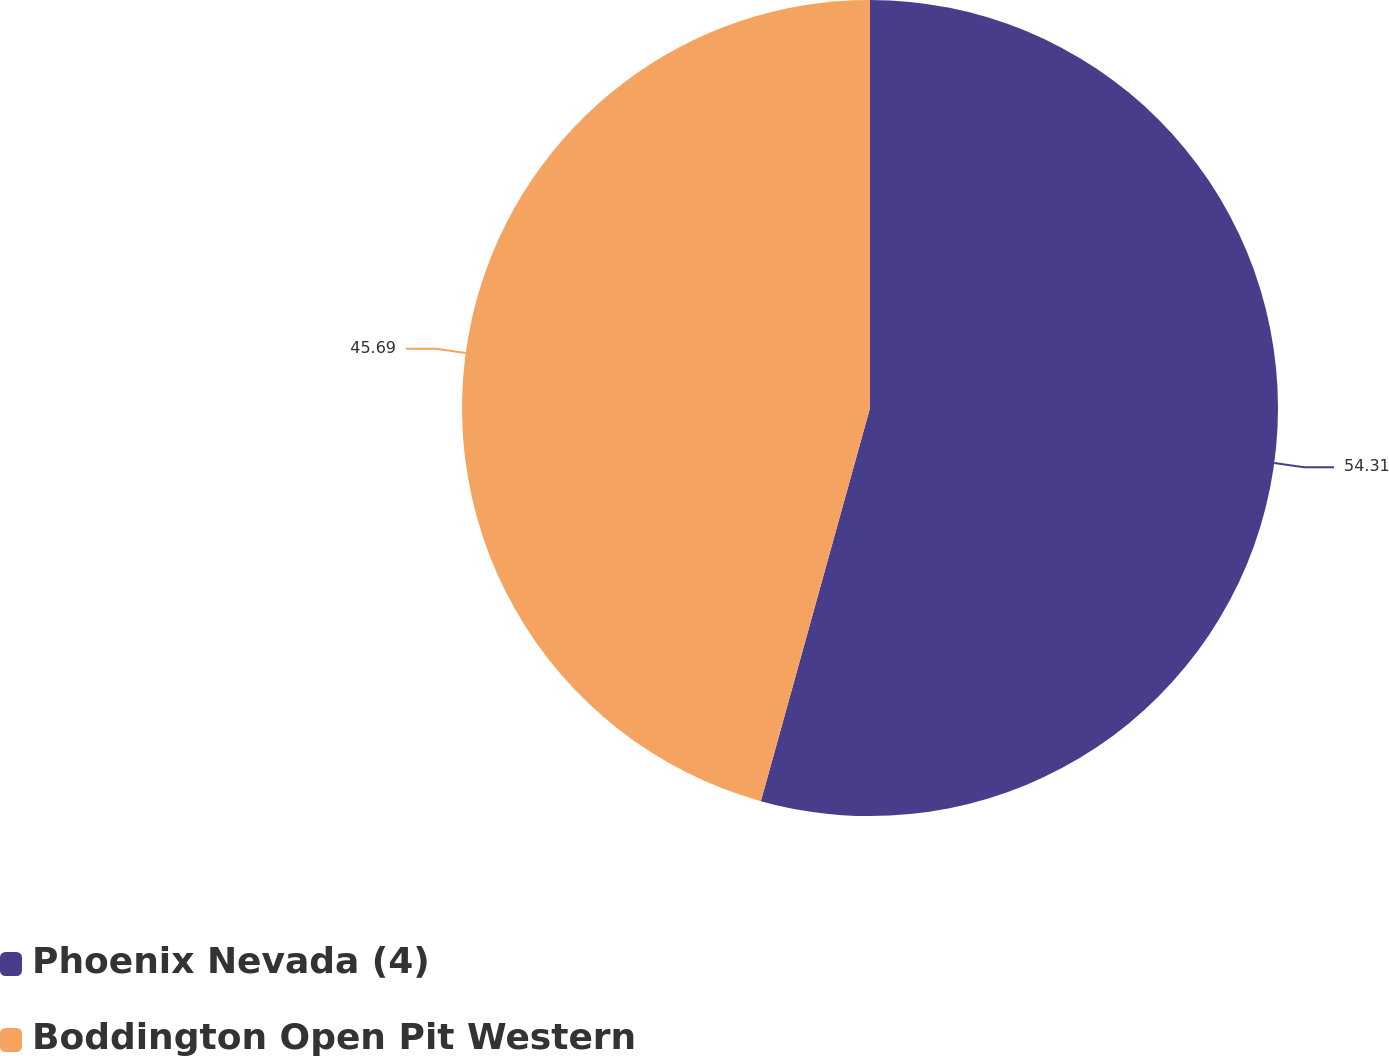<chart> <loc_0><loc_0><loc_500><loc_500><pie_chart><fcel>Phoenix Nevada (4)<fcel>Boddington Open Pit Western<nl><fcel>54.31%<fcel>45.69%<nl></chart> 